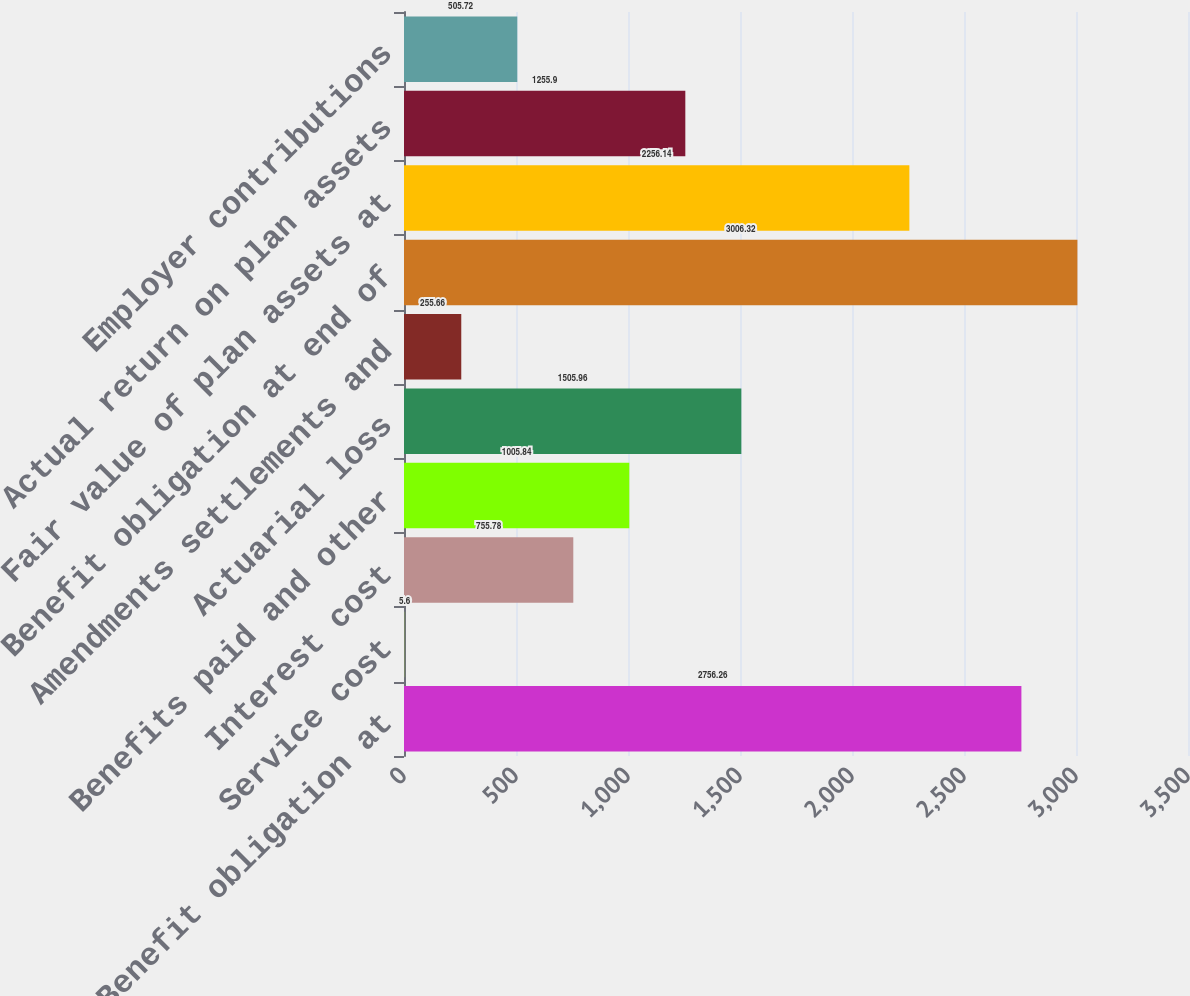Convert chart to OTSL. <chart><loc_0><loc_0><loc_500><loc_500><bar_chart><fcel>Benefit obligation at<fcel>Service cost<fcel>Interest cost<fcel>Benefits paid and other<fcel>Actuarial loss<fcel>Amendments settlements and<fcel>Benefit obligation at end of<fcel>Fair value of plan assets at<fcel>Actual return on plan assets<fcel>Employer contributions<nl><fcel>2756.26<fcel>5.6<fcel>755.78<fcel>1005.84<fcel>1505.96<fcel>255.66<fcel>3006.32<fcel>2256.14<fcel>1255.9<fcel>505.72<nl></chart> 